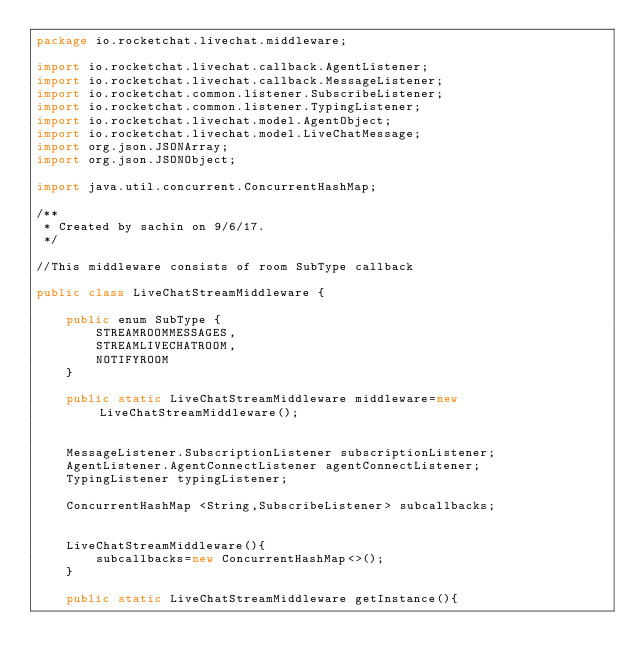Convert code to text. <code><loc_0><loc_0><loc_500><loc_500><_Java_>package io.rocketchat.livechat.middleware;

import io.rocketchat.livechat.callback.AgentListener;
import io.rocketchat.livechat.callback.MessageListener;
import io.rocketchat.common.listener.SubscribeListener;
import io.rocketchat.common.listener.TypingListener;
import io.rocketchat.livechat.model.AgentObject;
import io.rocketchat.livechat.model.LiveChatMessage;
import org.json.JSONArray;
import org.json.JSONObject;

import java.util.concurrent.ConcurrentHashMap;

/**
 * Created by sachin on 9/6/17.
 */

//This middleware consists of room SubType callback

public class LiveChatStreamMiddleware {

    public enum SubType {
        STREAMROOMMESSAGES,
        STREAMLIVECHATROOM,
        NOTIFYROOM
    }

    public static LiveChatStreamMiddleware middleware=new LiveChatStreamMiddleware();


    MessageListener.SubscriptionListener subscriptionListener;
    AgentListener.AgentConnectListener agentConnectListener;
    TypingListener typingListener;

    ConcurrentHashMap <String,SubscribeListener> subcallbacks;


    LiveChatStreamMiddleware(){
        subcallbacks=new ConcurrentHashMap<>();
    }

    public static LiveChatStreamMiddleware getInstance(){</code> 